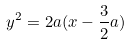<formula> <loc_0><loc_0><loc_500><loc_500>y ^ { 2 } = 2 a ( x - \frac { 3 } { 2 } a )</formula> 